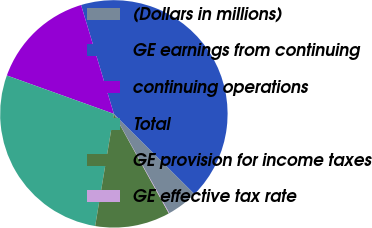Convert chart. <chart><loc_0><loc_0><loc_500><loc_500><pie_chart><fcel>(Dollars in millions)<fcel>GE earnings from continuing<fcel>continuing operations<fcel>Total<fcel>GE provision for income taxes<fcel>GE effective tax rate<nl><fcel>4.43%<fcel>42.12%<fcel>14.86%<fcel>27.85%<fcel>10.66%<fcel>0.08%<nl></chart> 